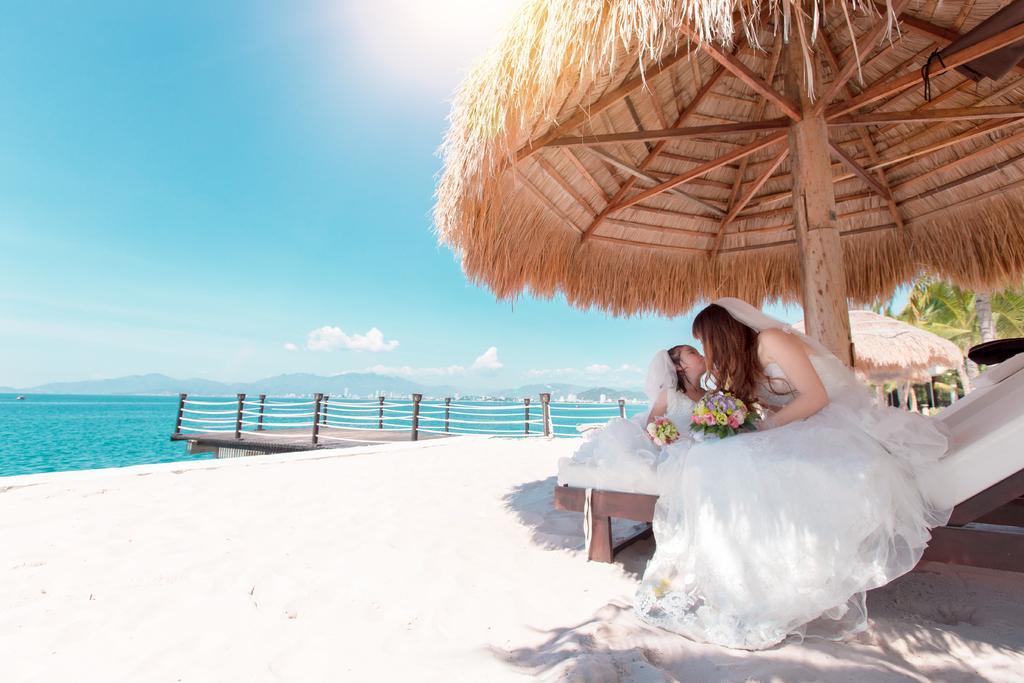How would you summarize this image in a sentence or two? In this image we can see a woman and a girl holding bouquets in their hands and sitting on the chaise lounge under a parasol. In the background there are walkway bridge, seashore, sea, hills and sky with clouds. 